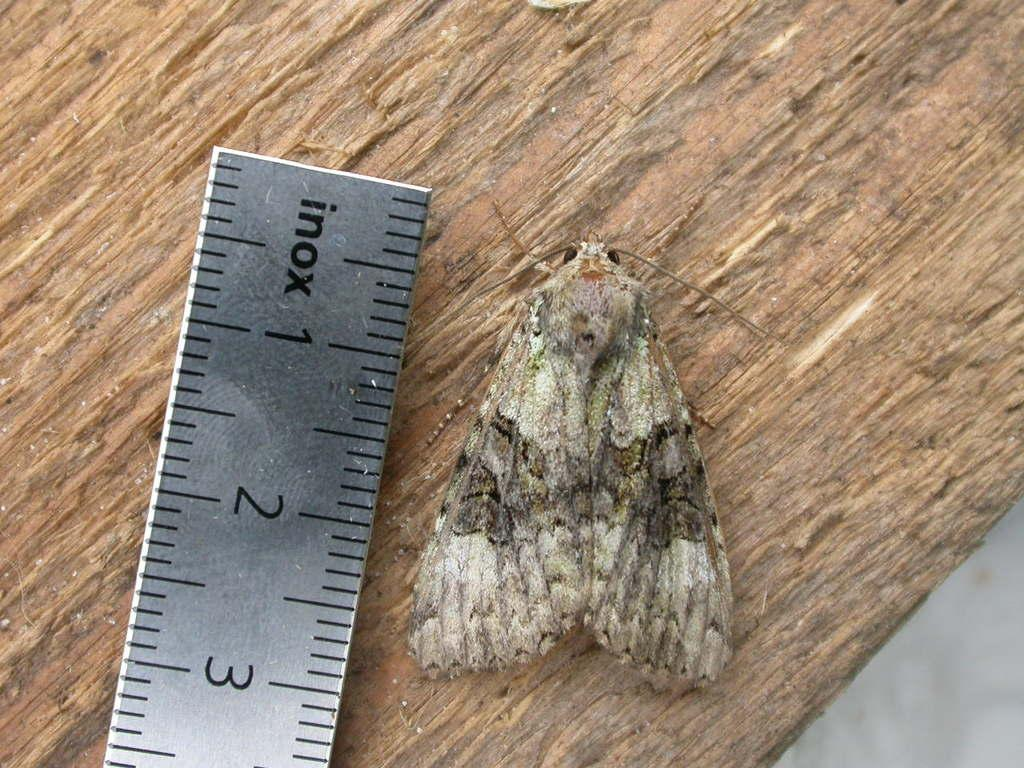<image>
Summarize the visual content of the image. Ruler measure a moth with the word "inox" on it. 